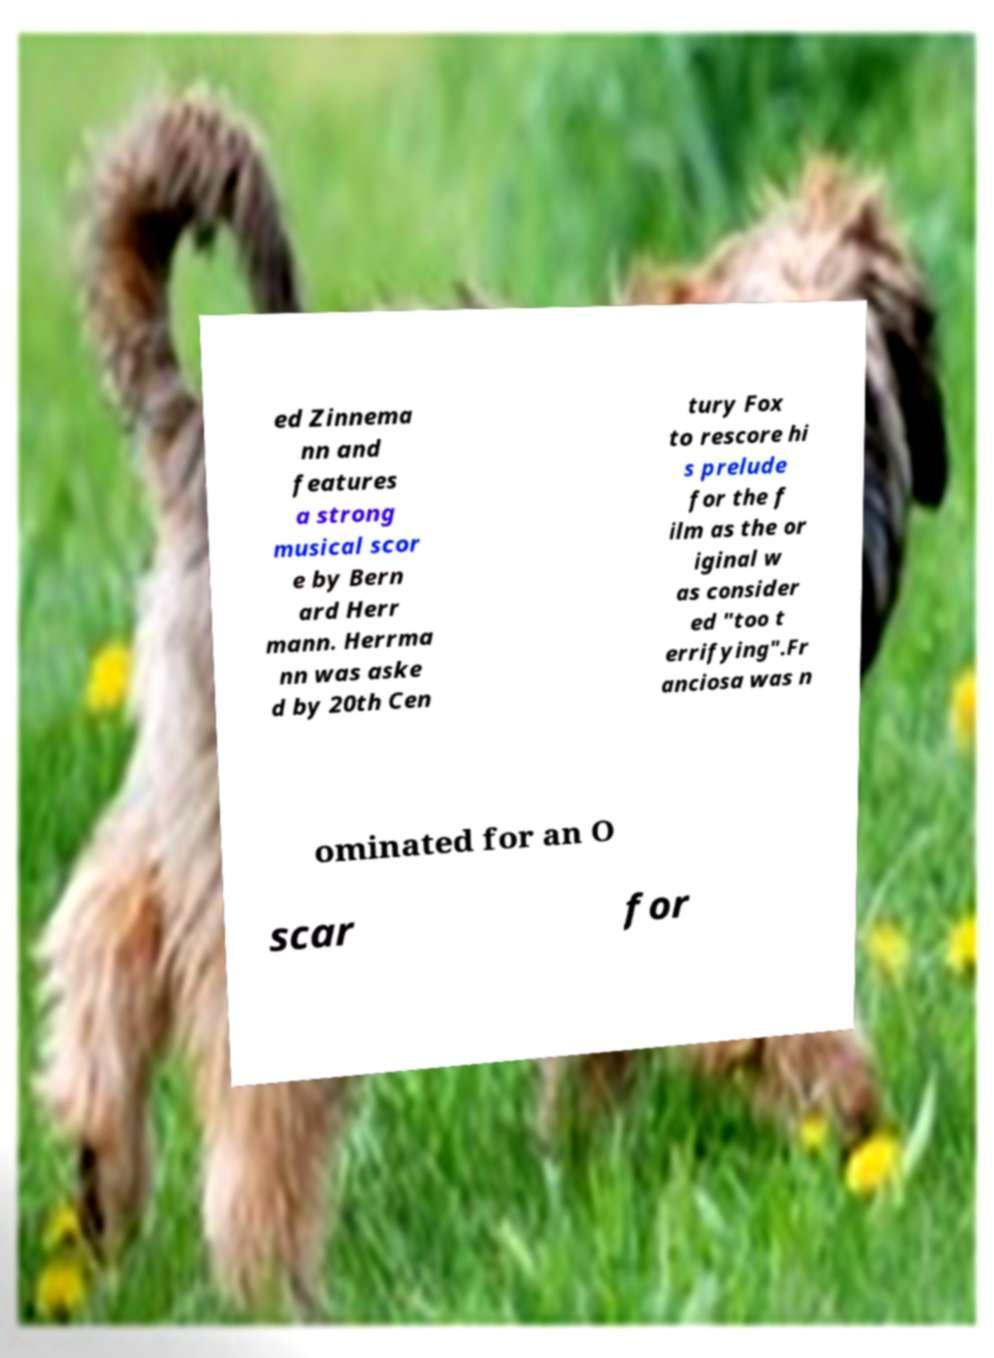I need the written content from this picture converted into text. Can you do that? ed Zinnema nn and features a strong musical scor e by Bern ard Herr mann. Herrma nn was aske d by 20th Cen tury Fox to rescore hi s prelude for the f ilm as the or iginal w as consider ed "too t errifying".Fr anciosa was n ominated for an O scar for 